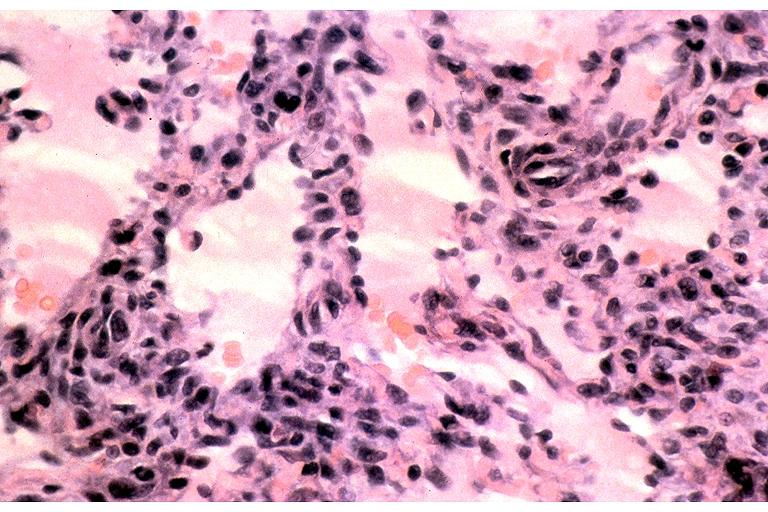what does this image show?
Answer the question using a single word or phrase. Kaposi sarcoma 